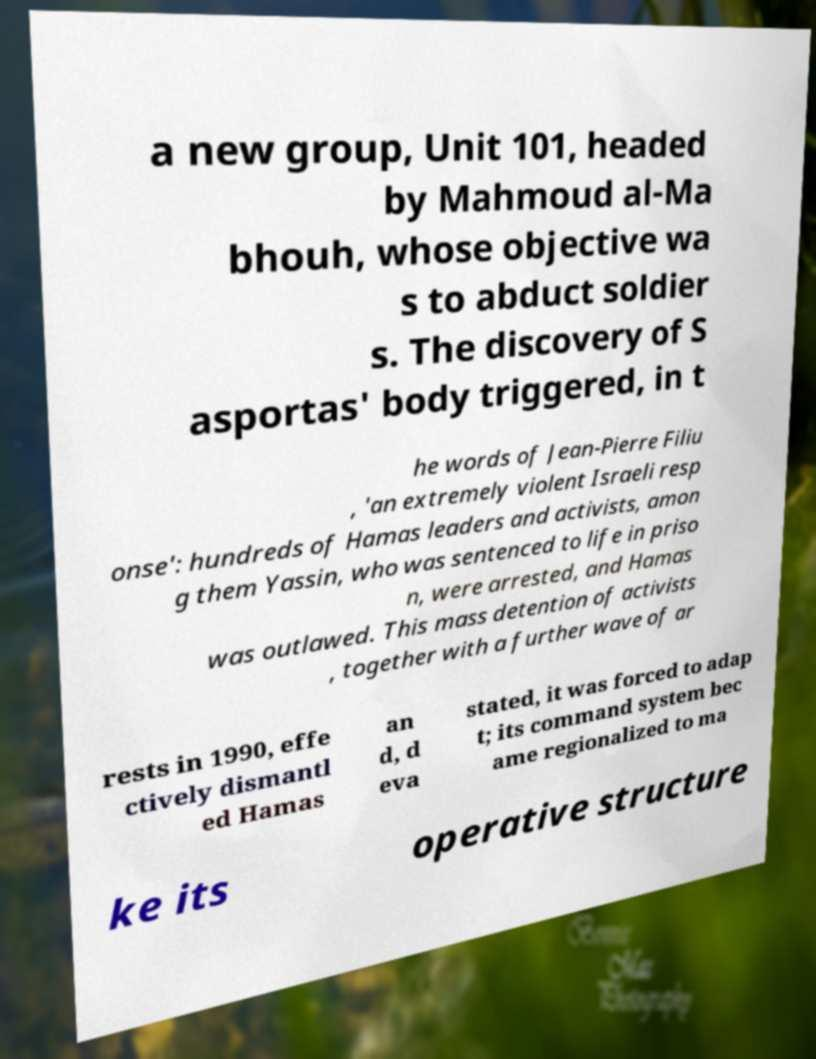Could you assist in decoding the text presented in this image and type it out clearly? a new group, Unit 101, headed by Mahmoud al-Ma bhouh, whose objective wa s to abduct soldier s. The discovery of S asportas' body triggered, in t he words of Jean-Pierre Filiu , 'an extremely violent Israeli resp onse': hundreds of Hamas leaders and activists, amon g them Yassin, who was sentenced to life in priso n, were arrested, and Hamas was outlawed. This mass detention of activists , together with a further wave of ar rests in 1990, effe ctively dismantl ed Hamas an d, d eva stated, it was forced to adap t; its command system bec ame regionalized to ma ke its operative structure 